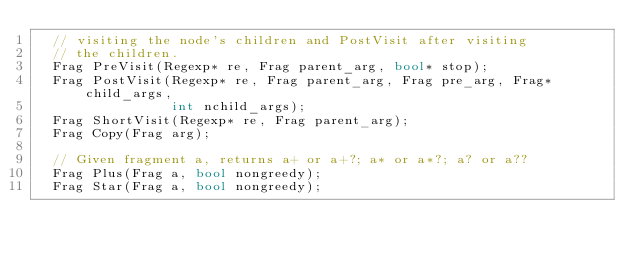<code> <loc_0><loc_0><loc_500><loc_500><_C++_>  // visiting the node's children and PostVisit after visiting
  // the children.
  Frag PreVisit(Regexp* re, Frag parent_arg, bool* stop);
  Frag PostVisit(Regexp* re, Frag parent_arg, Frag pre_arg, Frag* child_args,
                 int nchild_args);
  Frag ShortVisit(Regexp* re, Frag parent_arg);
  Frag Copy(Frag arg);

  // Given fragment a, returns a+ or a+?; a* or a*?; a? or a??
  Frag Plus(Frag a, bool nongreedy);
  Frag Star(Frag a, bool nongreedy);</code> 